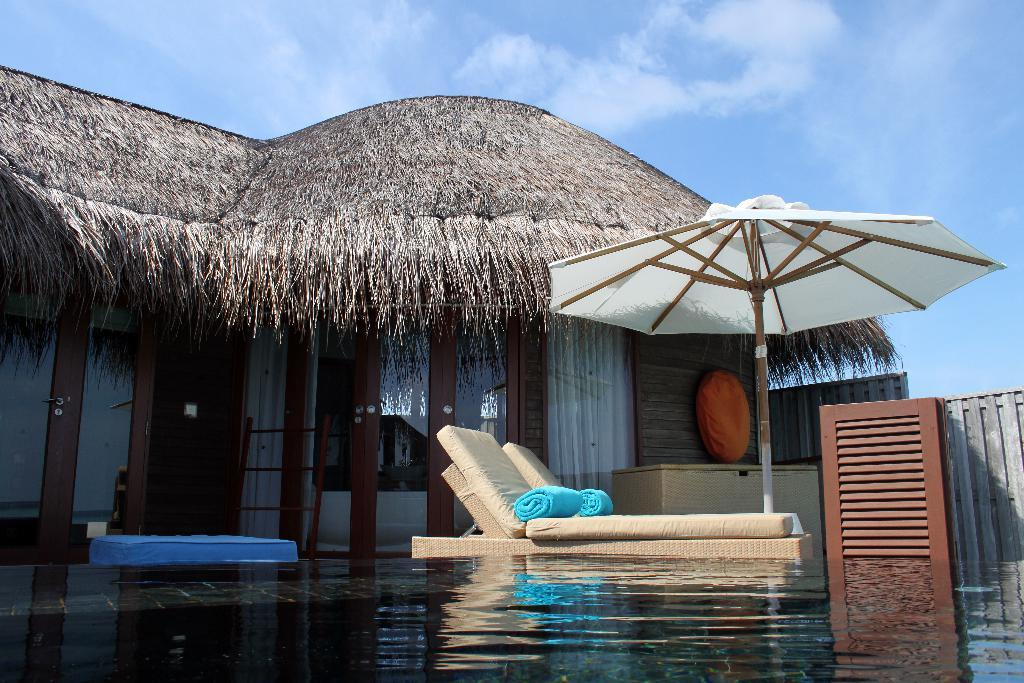What is present in the image that indicates a water source? There is water visible in the image. What type of seating is available in the image? There is a rest chair in the image. What is used for shade in the image? There is an umbrella in the image. What type of house can be seen in the image? There is a house with a thatched roof in the image. What type of cheese is being served with the popcorn in the image? There is no cheese or popcorn present in the image. Can you describe the goat that is grazing near the house in the image? There is no goat present in the image. 